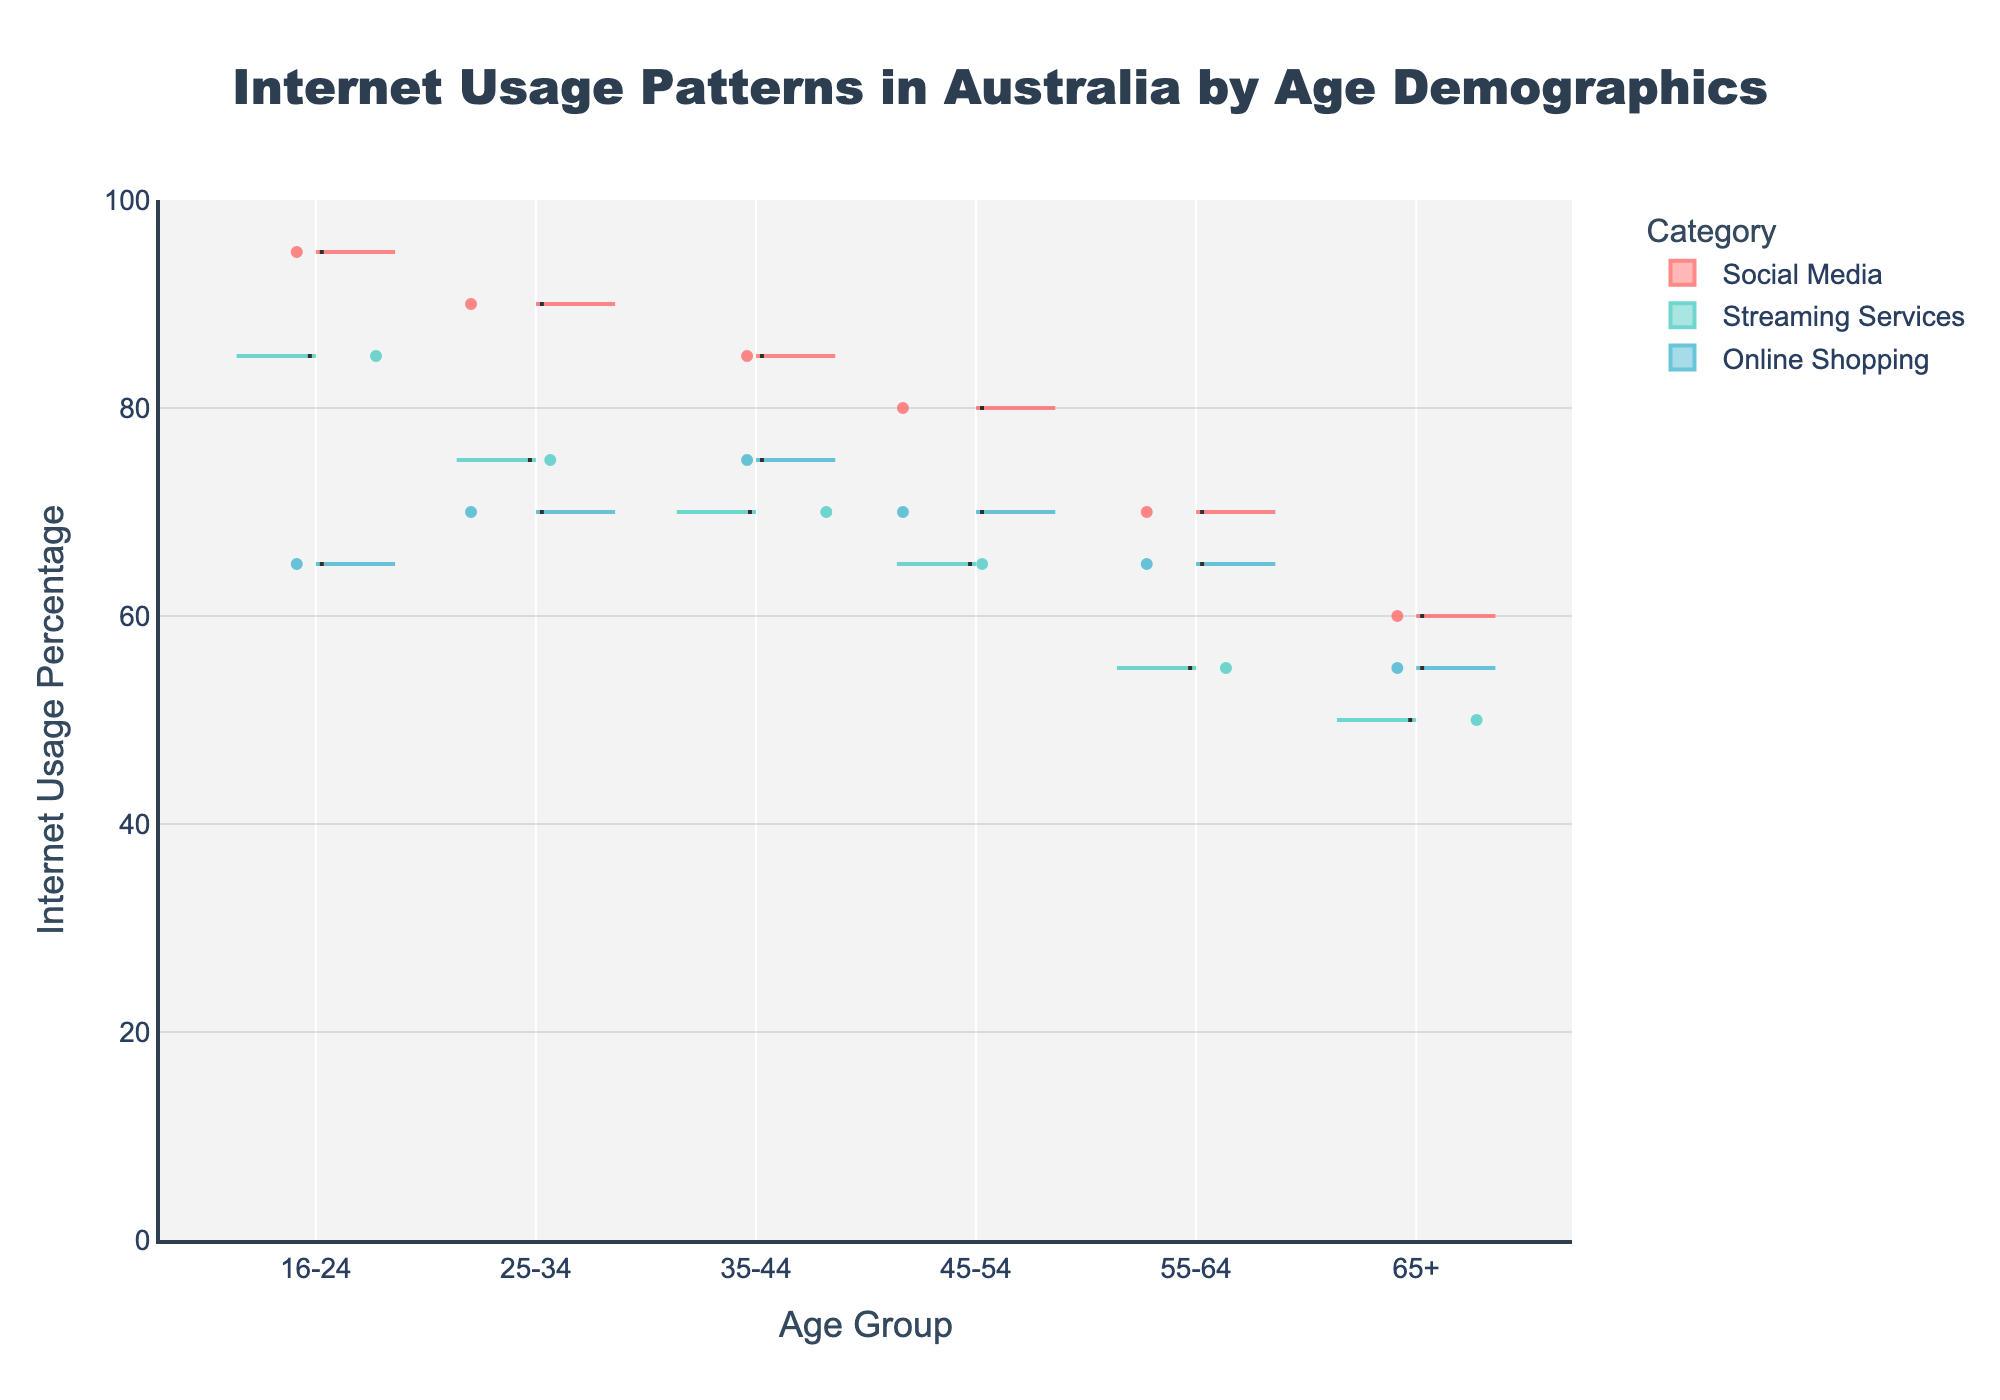What is the title of the plot? The title of the plot is displayed at the top of the figure and can easily be read. The text is in a larger font size than other elements in the chart.
Answer: Internet Usage Patterns in Australia by Age Demographics Which age group has the highest percentage of internet usage for social media? Look at the violin plot segments labeled "Social Media" across different age groups and identify the highest point.
Answer: 16-24 For the age group 45-54, how does the internet usage for online shopping compare to streaming services? Examine the violin plots for the age group 45-54. Compare the y-values of the "Online Shopping" and "Streaming Services" plots.
Answer: Internet usage for online shopping is higher What is the range of internet usage percentage for the 65+ age group? Identify the minimum and maximum y-values for each violin plot segment corresponding to the 65+ age group. The range is from the lowest to the highest percentage shown.
Answer: 50-60 How does internet usage for online shopping change from the age group 16-24 to 25-34? Observe the violin plot representing "Online Shopping" for both the 16-24 and 25-34 age groups. Compare the internet usage percentages.
Answer: It increases Which category has the lowest internet usage percentage across all age groups? Look at the lowest points in the violin plots for each category across all age groups. The category with the overall lowest point is the answer.
Answer: Streaming Services How do the internet usage percentages for streaming services differ between the age groups 35-44 and 55-64? Compare the violin plots for "Streaming Services" in the age groups 35-44 and 55-64. Take note of the y-values to show the difference.
Answer: It’s higher in the 35-44 age group What is the mean internet usage percentage for social media in the 25-34 age group? Find the point marked by the mean line on the "Social Media" violin plot segment for the 25-34 age group.
Answer: 90 Which age group shows the most variance in internet usage for online shopping? Evaluate the width and spread of the violin plots for "Online Shopping" across different age groups. The most spread-out (widest) plot indicates the most variance.
Answer: 45-54 Compare the internet usage for social media between the youngest and the oldest age groups. Look at the violin plots for "Social Media" for the age groups 16-24 and 65+. Compare the usage percentages by noting the difference in the y-values.
Answer: It is higher for the youngest age group (16-24) 